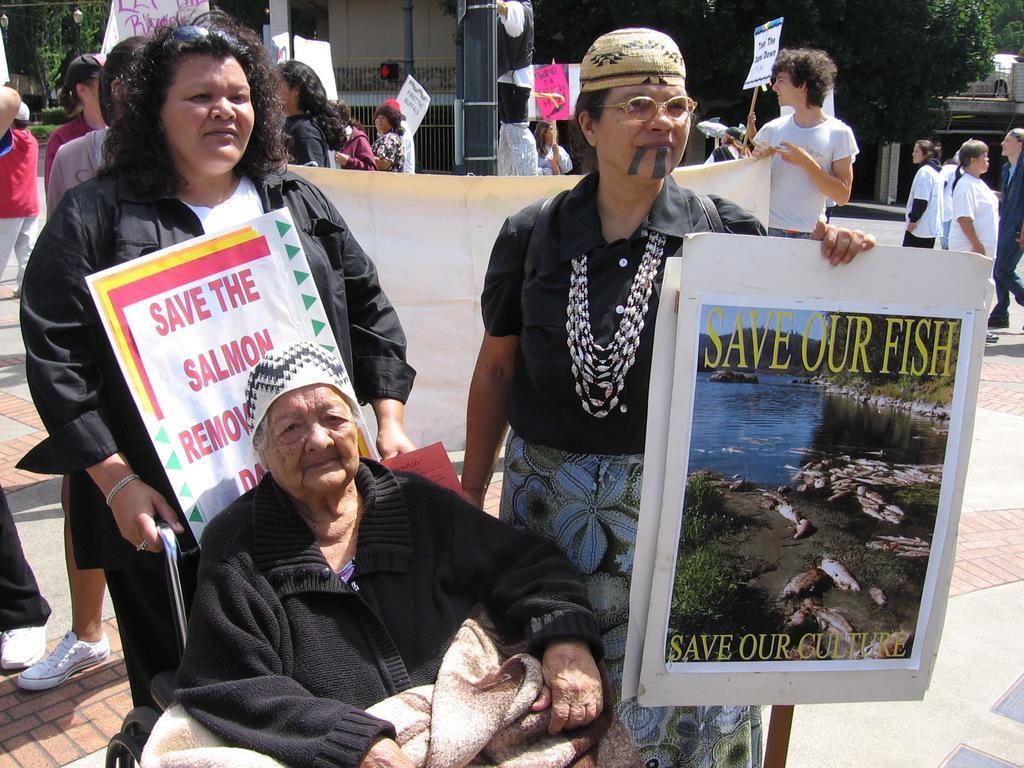Describe this image in one or two sentences. In this picture I can see a person sitting on the chair, there are group of people standing and holding placards, and in the background there are trees, iron grilles and some other objects. 